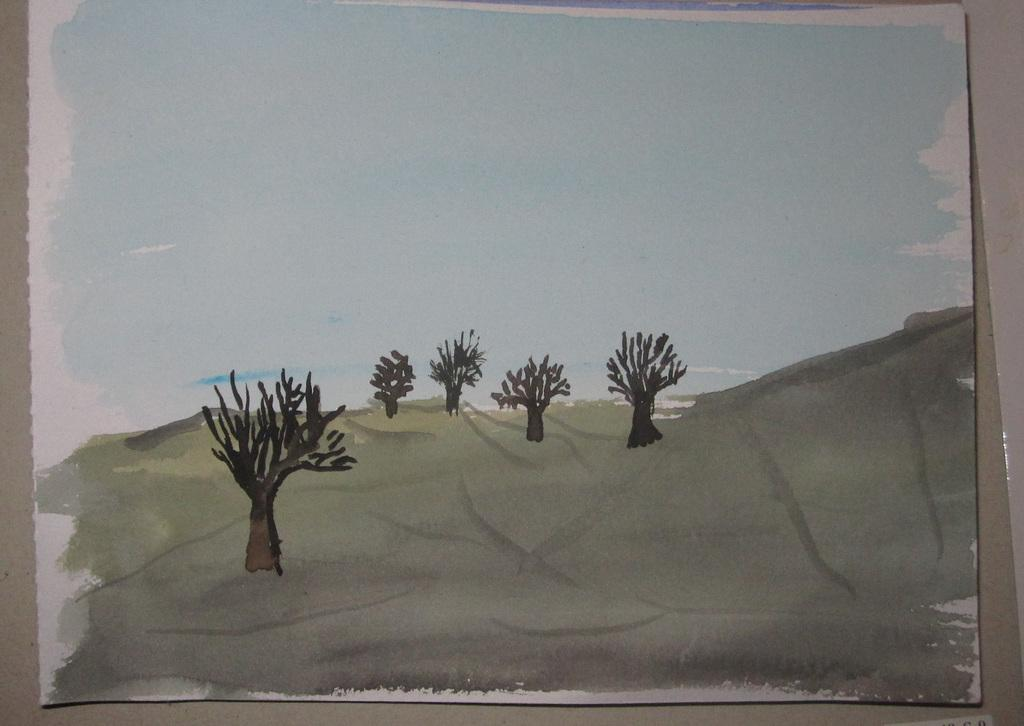What type of artwork is depicted in the image? The image is a painting. What natural elements can be seen in the painting? There are trees in the painting. What is visible in the background of the painting? The sky is visible in the background of the painting. How many boys are sitting on the rock in the painting? There are no boys or rocks present in the painting; it features trees and a sky. 